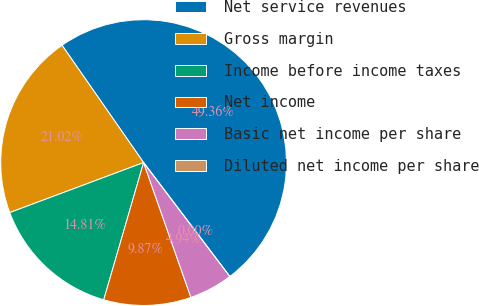Convert chart. <chart><loc_0><loc_0><loc_500><loc_500><pie_chart><fcel>Net service revenues<fcel>Gross margin<fcel>Income before income taxes<fcel>Net income<fcel>Basic net income per share<fcel>Diluted net income per share<nl><fcel>49.36%<fcel>21.02%<fcel>14.81%<fcel>9.87%<fcel>4.94%<fcel>0.0%<nl></chart> 